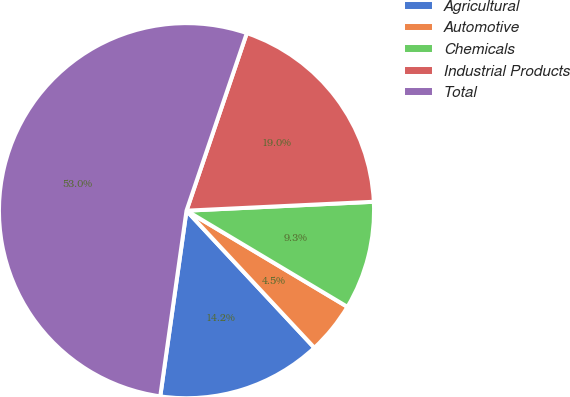<chart> <loc_0><loc_0><loc_500><loc_500><pie_chart><fcel>Agricultural<fcel>Automotive<fcel>Chemicals<fcel>Industrial Products<fcel>Total<nl><fcel>14.18%<fcel>4.48%<fcel>9.33%<fcel>19.03%<fcel>52.97%<nl></chart> 